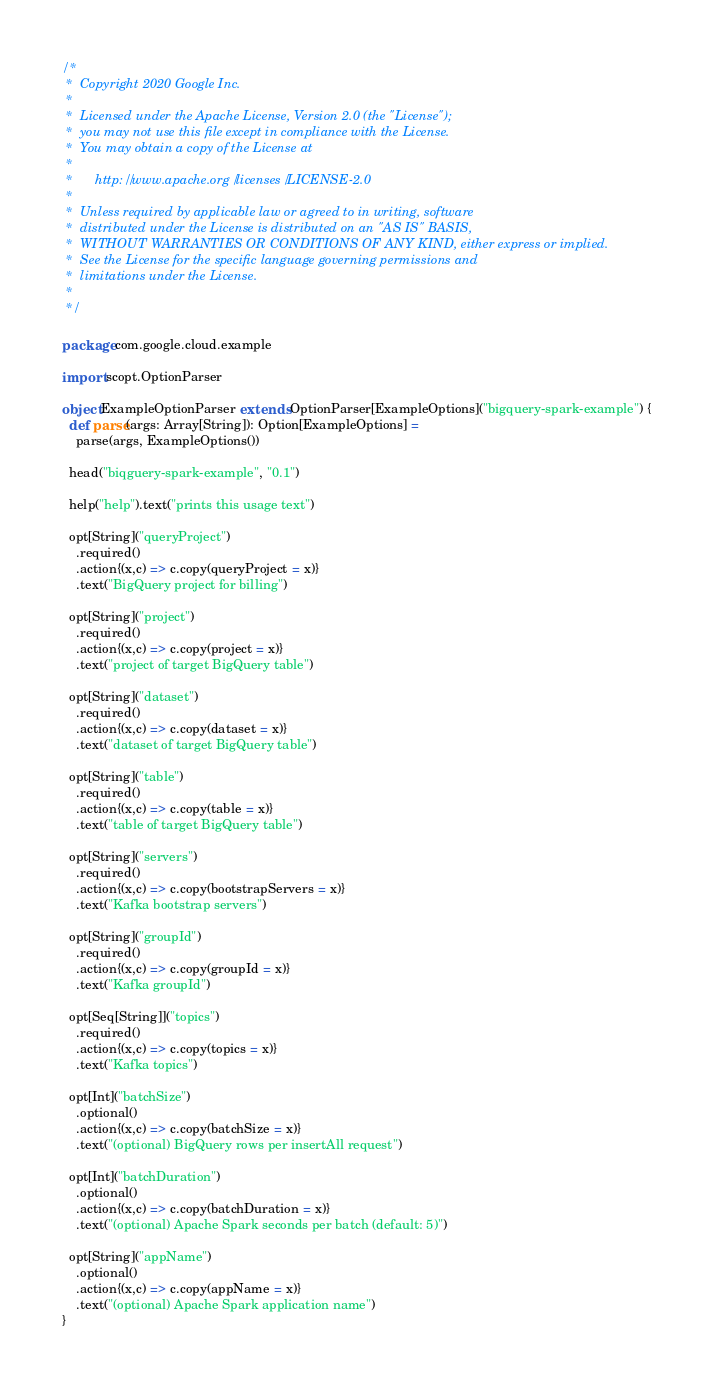Convert code to text. <code><loc_0><loc_0><loc_500><loc_500><_Scala_>/*
 *  Copyright 2020 Google Inc.
 *
 *  Licensed under the Apache License, Version 2.0 (the "License");
 *  you may not use this file except in compliance with the License.
 *  You may obtain a copy of the License at
 *
 *      http://www.apache.org/licenses/LICENSE-2.0
 *
 *  Unless required by applicable law or agreed to in writing, software
 *  distributed under the License is distributed on an "AS IS" BASIS,
 *  WITHOUT WARRANTIES OR CONDITIONS OF ANY KIND, either express or implied.
 *  See the License for the specific language governing permissions and
 *  limitations under the License.
 *
 */

package com.google.cloud.example

import scopt.OptionParser

object ExampleOptionParser extends OptionParser[ExampleOptions]("bigquery-spark-example") {
  def parse(args: Array[String]): Option[ExampleOptions] =
    parse(args, ExampleOptions())

  head("biqguery-spark-example", "0.1")

  help("help").text("prints this usage text")

  opt[String]("queryProject")
    .required()
    .action{(x,c) => c.copy(queryProject = x)}
    .text("BigQuery project for billing")

  opt[String]("project")
    .required()
    .action{(x,c) => c.copy(project = x)}
    .text("project of target BigQuery table")

  opt[String]("dataset")
    .required()
    .action{(x,c) => c.copy(dataset = x)}
    .text("dataset of target BigQuery table")

  opt[String]("table")
    .required()
    .action{(x,c) => c.copy(table = x)}
    .text("table of target BigQuery table")

  opt[String]("servers")
    .required()
    .action{(x,c) => c.copy(bootstrapServers = x)}
    .text("Kafka bootstrap servers")

  opt[String]("groupId")
    .required()
    .action{(x,c) => c.copy(groupId = x)}
    .text("Kafka groupId")

  opt[Seq[String]]("topics")
    .required()
    .action{(x,c) => c.copy(topics = x)}
    .text("Kafka topics")

  opt[Int]("batchSize")
    .optional()
    .action{(x,c) => c.copy(batchSize = x)}
    .text("(optional) BigQuery rows per insertAll request")

  opt[Int]("batchDuration")
    .optional()
    .action{(x,c) => c.copy(batchDuration = x)}
    .text("(optional) Apache Spark seconds per batch (default: 5)")

  opt[String]("appName")
    .optional()
    .action{(x,c) => c.copy(appName = x)}
    .text("(optional) Apache Spark application name")
}

</code> 